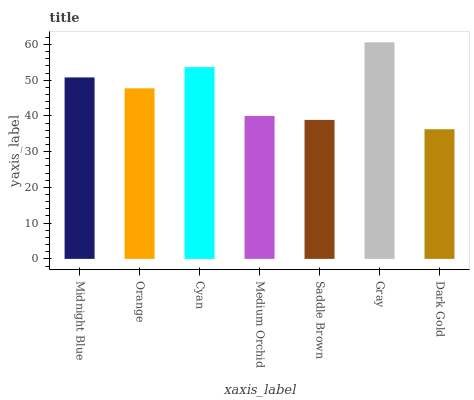Is Orange the minimum?
Answer yes or no. No. Is Orange the maximum?
Answer yes or no. No. Is Midnight Blue greater than Orange?
Answer yes or no. Yes. Is Orange less than Midnight Blue?
Answer yes or no. Yes. Is Orange greater than Midnight Blue?
Answer yes or no. No. Is Midnight Blue less than Orange?
Answer yes or no. No. Is Orange the high median?
Answer yes or no. Yes. Is Orange the low median?
Answer yes or no. Yes. Is Gray the high median?
Answer yes or no. No. Is Medium Orchid the low median?
Answer yes or no. No. 